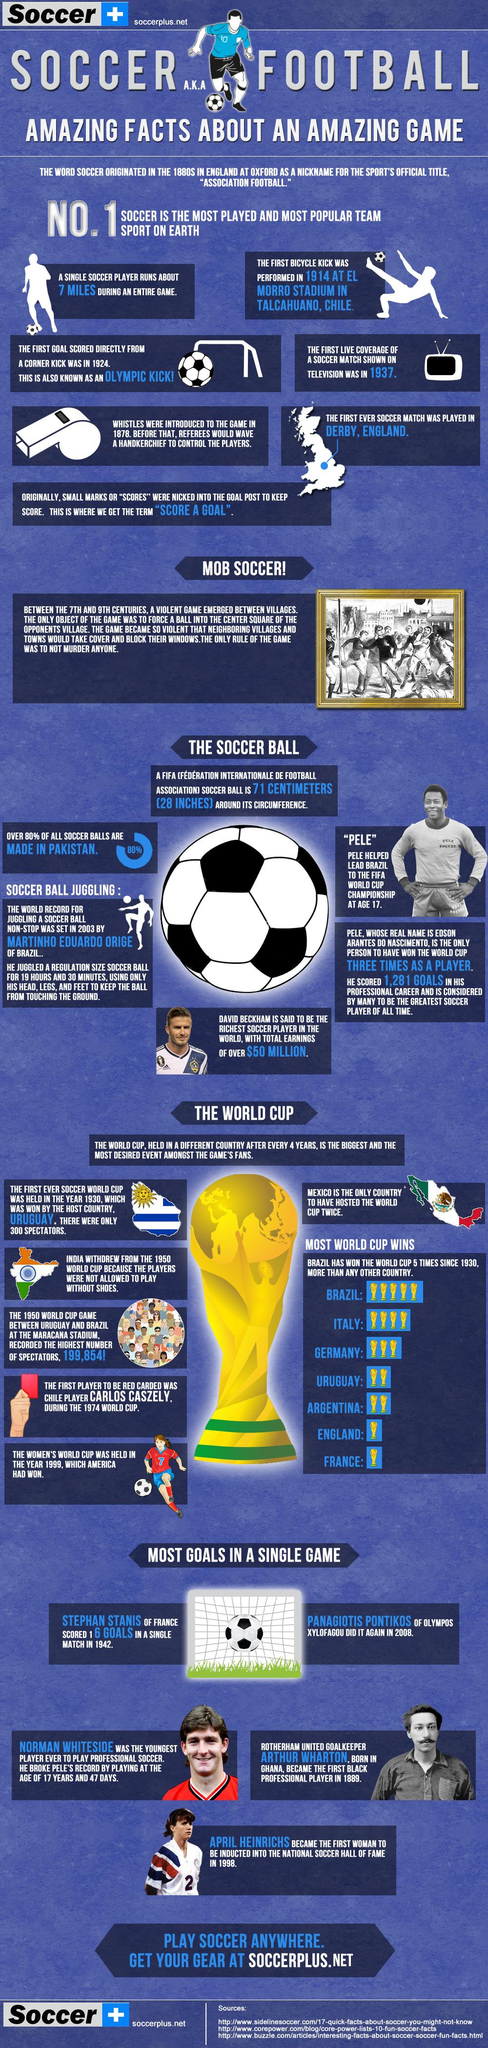Mention a couple of crucial points in this snapshot. England and France are countries that have won the FIFA World Cup once. At the age of 17, Edson Arantes Do Nascimento led Brazil to victory at the FIFA World Cup Championship. The first Olympic kick was scored in 1924. Pakistan produces the largest quantity of soccer balls among all countries. Uruguay and Argentina have both won the FIFA World Cup twice. 